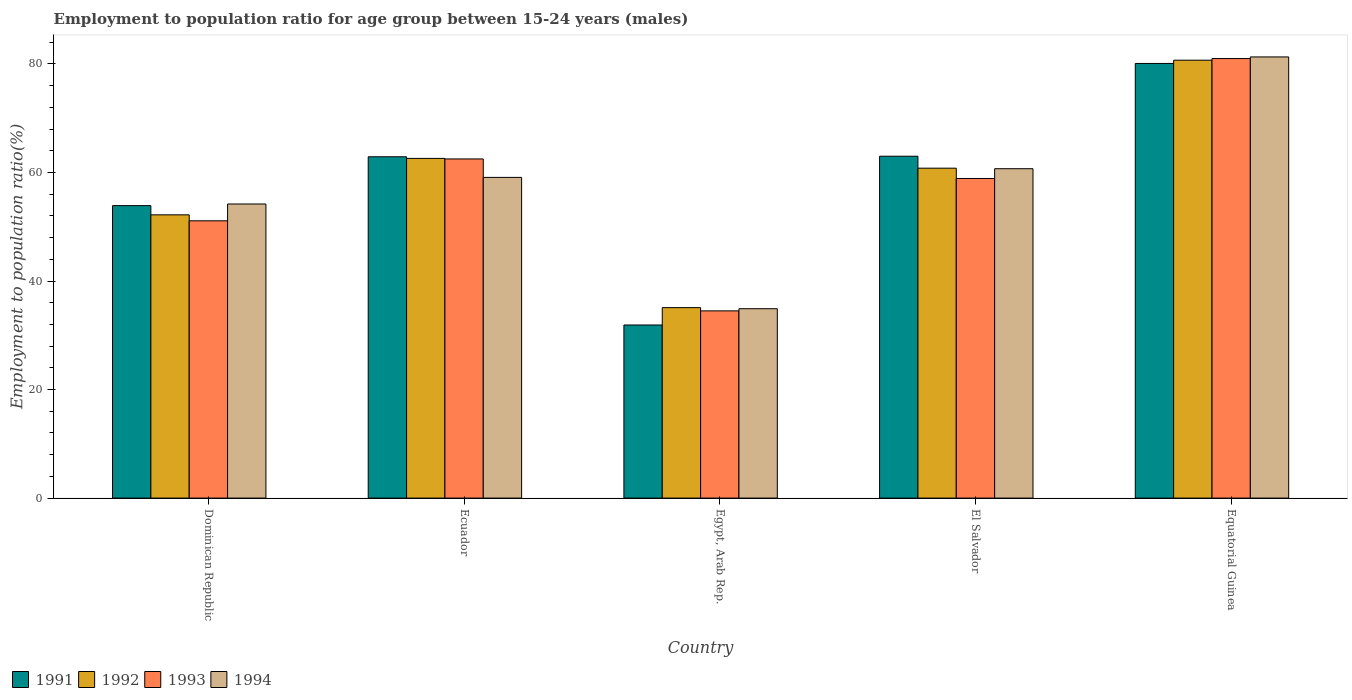How many different coloured bars are there?
Offer a very short reply. 4. How many bars are there on the 3rd tick from the left?
Keep it short and to the point. 4. How many bars are there on the 1st tick from the right?
Make the answer very short. 4. What is the label of the 1st group of bars from the left?
Keep it short and to the point. Dominican Republic. In how many cases, is the number of bars for a given country not equal to the number of legend labels?
Make the answer very short. 0. What is the employment to population ratio in 1994 in Ecuador?
Ensure brevity in your answer.  59.1. Across all countries, what is the maximum employment to population ratio in 1991?
Your answer should be very brief. 80.1. Across all countries, what is the minimum employment to population ratio in 1992?
Your response must be concise. 35.1. In which country was the employment to population ratio in 1991 maximum?
Give a very brief answer. Equatorial Guinea. In which country was the employment to population ratio in 1993 minimum?
Ensure brevity in your answer.  Egypt, Arab Rep. What is the total employment to population ratio in 1991 in the graph?
Offer a very short reply. 291.8. What is the difference between the employment to population ratio in 1994 in Ecuador and that in Egypt, Arab Rep.?
Give a very brief answer. 24.2. What is the difference between the employment to population ratio in 1994 in Equatorial Guinea and the employment to population ratio in 1993 in Ecuador?
Your response must be concise. 18.8. What is the average employment to population ratio in 1992 per country?
Make the answer very short. 58.28. What is the difference between the employment to population ratio of/in 1992 and employment to population ratio of/in 1993 in Egypt, Arab Rep.?
Make the answer very short. 0.6. What is the ratio of the employment to population ratio in 1994 in Ecuador to that in Equatorial Guinea?
Provide a succinct answer. 0.73. Is the difference between the employment to population ratio in 1992 in Dominican Republic and El Salvador greater than the difference between the employment to population ratio in 1993 in Dominican Republic and El Salvador?
Offer a very short reply. No. What is the difference between the highest and the second highest employment to population ratio in 1993?
Offer a terse response. 22.1. What is the difference between the highest and the lowest employment to population ratio in 1993?
Provide a short and direct response. 46.5. Is the sum of the employment to population ratio in 1993 in Dominican Republic and Equatorial Guinea greater than the maximum employment to population ratio in 1994 across all countries?
Your response must be concise. Yes. What does the 2nd bar from the right in Egypt, Arab Rep. represents?
Your answer should be very brief. 1993. Are all the bars in the graph horizontal?
Your answer should be very brief. No. Are the values on the major ticks of Y-axis written in scientific E-notation?
Your answer should be compact. No. How many legend labels are there?
Provide a short and direct response. 4. What is the title of the graph?
Your response must be concise. Employment to population ratio for age group between 15-24 years (males). What is the label or title of the X-axis?
Your answer should be very brief. Country. What is the Employment to population ratio(%) in 1991 in Dominican Republic?
Give a very brief answer. 53.9. What is the Employment to population ratio(%) in 1992 in Dominican Republic?
Provide a succinct answer. 52.2. What is the Employment to population ratio(%) of 1993 in Dominican Republic?
Provide a succinct answer. 51.1. What is the Employment to population ratio(%) in 1994 in Dominican Republic?
Your answer should be compact. 54.2. What is the Employment to population ratio(%) of 1991 in Ecuador?
Provide a succinct answer. 62.9. What is the Employment to population ratio(%) in 1992 in Ecuador?
Give a very brief answer. 62.6. What is the Employment to population ratio(%) in 1993 in Ecuador?
Offer a terse response. 62.5. What is the Employment to population ratio(%) of 1994 in Ecuador?
Your response must be concise. 59.1. What is the Employment to population ratio(%) in 1991 in Egypt, Arab Rep.?
Make the answer very short. 31.9. What is the Employment to population ratio(%) of 1992 in Egypt, Arab Rep.?
Provide a short and direct response. 35.1. What is the Employment to population ratio(%) in 1993 in Egypt, Arab Rep.?
Make the answer very short. 34.5. What is the Employment to population ratio(%) in 1994 in Egypt, Arab Rep.?
Provide a short and direct response. 34.9. What is the Employment to population ratio(%) in 1991 in El Salvador?
Ensure brevity in your answer.  63. What is the Employment to population ratio(%) in 1992 in El Salvador?
Your response must be concise. 60.8. What is the Employment to population ratio(%) in 1993 in El Salvador?
Offer a terse response. 58.9. What is the Employment to population ratio(%) in 1994 in El Salvador?
Your answer should be very brief. 60.7. What is the Employment to population ratio(%) in 1991 in Equatorial Guinea?
Offer a terse response. 80.1. What is the Employment to population ratio(%) in 1992 in Equatorial Guinea?
Offer a terse response. 80.7. What is the Employment to population ratio(%) in 1993 in Equatorial Guinea?
Your response must be concise. 81. What is the Employment to population ratio(%) in 1994 in Equatorial Guinea?
Offer a terse response. 81.3. Across all countries, what is the maximum Employment to population ratio(%) of 1991?
Make the answer very short. 80.1. Across all countries, what is the maximum Employment to population ratio(%) in 1992?
Provide a short and direct response. 80.7. Across all countries, what is the maximum Employment to population ratio(%) in 1994?
Give a very brief answer. 81.3. Across all countries, what is the minimum Employment to population ratio(%) of 1991?
Ensure brevity in your answer.  31.9. Across all countries, what is the minimum Employment to population ratio(%) of 1992?
Keep it short and to the point. 35.1. Across all countries, what is the minimum Employment to population ratio(%) in 1993?
Offer a terse response. 34.5. Across all countries, what is the minimum Employment to population ratio(%) in 1994?
Keep it short and to the point. 34.9. What is the total Employment to population ratio(%) of 1991 in the graph?
Make the answer very short. 291.8. What is the total Employment to population ratio(%) of 1992 in the graph?
Your response must be concise. 291.4. What is the total Employment to population ratio(%) in 1993 in the graph?
Provide a succinct answer. 288. What is the total Employment to population ratio(%) in 1994 in the graph?
Make the answer very short. 290.2. What is the difference between the Employment to population ratio(%) in 1993 in Dominican Republic and that in Ecuador?
Keep it short and to the point. -11.4. What is the difference between the Employment to population ratio(%) of 1994 in Dominican Republic and that in Ecuador?
Your response must be concise. -4.9. What is the difference between the Employment to population ratio(%) of 1991 in Dominican Republic and that in Egypt, Arab Rep.?
Your answer should be compact. 22. What is the difference between the Employment to population ratio(%) in 1992 in Dominican Republic and that in Egypt, Arab Rep.?
Provide a succinct answer. 17.1. What is the difference between the Employment to population ratio(%) in 1993 in Dominican Republic and that in Egypt, Arab Rep.?
Your answer should be compact. 16.6. What is the difference between the Employment to population ratio(%) in 1994 in Dominican Republic and that in Egypt, Arab Rep.?
Make the answer very short. 19.3. What is the difference between the Employment to population ratio(%) in 1992 in Dominican Republic and that in El Salvador?
Offer a very short reply. -8.6. What is the difference between the Employment to population ratio(%) of 1993 in Dominican Republic and that in El Salvador?
Your response must be concise. -7.8. What is the difference between the Employment to population ratio(%) in 1991 in Dominican Republic and that in Equatorial Guinea?
Ensure brevity in your answer.  -26.2. What is the difference between the Employment to population ratio(%) in 1992 in Dominican Republic and that in Equatorial Guinea?
Ensure brevity in your answer.  -28.5. What is the difference between the Employment to population ratio(%) of 1993 in Dominican Republic and that in Equatorial Guinea?
Offer a terse response. -29.9. What is the difference between the Employment to population ratio(%) of 1994 in Dominican Republic and that in Equatorial Guinea?
Your answer should be very brief. -27.1. What is the difference between the Employment to population ratio(%) in 1993 in Ecuador and that in Egypt, Arab Rep.?
Offer a very short reply. 28. What is the difference between the Employment to population ratio(%) of 1994 in Ecuador and that in Egypt, Arab Rep.?
Offer a terse response. 24.2. What is the difference between the Employment to population ratio(%) of 1993 in Ecuador and that in El Salvador?
Offer a very short reply. 3.6. What is the difference between the Employment to population ratio(%) in 1994 in Ecuador and that in El Salvador?
Your answer should be compact. -1.6. What is the difference between the Employment to population ratio(%) of 1991 in Ecuador and that in Equatorial Guinea?
Keep it short and to the point. -17.2. What is the difference between the Employment to population ratio(%) in 1992 in Ecuador and that in Equatorial Guinea?
Ensure brevity in your answer.  -18.1. What is the difference between the Employment to population ratio(%) in 1993 in Ecuador and that in Equatorial Guinea?
Give a very brief answer. -18.5. What is the difference between the Employment to population ratio(%) in 1994 in Ecuador and that in Equatorial Guinea?
Provide a short and direct response. -22.2. What is the difference between the Employment to population ratio(%) in 1991 in Egypt, Arab Rep. and that in El Salvador?
Ensure brevity in your answer.  -31.1. What is the difference between the Employment to population ratio(%) of 1992 in Egypt, Arab Rep. and that in El Salvador?
Your response must be concise. -25.7. What is the difference between the Employment to population ratio(%) of 1993 in Egypt, Arab Rep. and that in El Salvador?
Offer a terse response. -24.4. What is the difference between the Employment to population ratio(%) of 1994 in Egypt, Arab Rep. and that in El Salvador?
Your response must be concise. -25.8. What is the difference between the Employment to population ratio(%) of 1991 in Egypt, Arab Rep. and that in Equatorial Guinea?
Offer a very short reply. -48.2. What is the difference between the Employment to population ratio(%) in 1992 in Egypt, Arab Rep. and that in Equatorial Guinea?
Provide a short and direct response. -45.6. What is the difference between the Employment to population ratio(%) of 1993 in Egypt, Arab Rep. and that in Equatorial Guinea?
Make the answer very short. -46.5. What is the difference between the Employment to population ratio(%) of 1994 in Egypt, Arab Rep. and that in Equatorial Guinea?
Make the answer very short. -46.4. What is the difference between the Employment to population ratio(%) in 1991 in El Salvador and that in Equatorial Guinea?
Your response must be concise. -17.1. What is the difference between the Employment to population ratio(%) in 1992 in El Salvador and that in Equatorial Guinea?
Your answer should be compact. -19.9. What is the difference between the Employment to population ratio(%) of 1993 in El Salvador and that in Equatorial Guinea?
Ensure brevity in your answer.  -22.1. What is the difference between the Employment to population ratio(%) in 1994 in El Salvador and that in Equatorial Guinea?
Provide a short and direct response. -20.6. What is the difference between the Employment to population ratio(%) of 1991 in Dominican Republic and the Employment to population ratio(%) of 1992 in Ecuador?
Offer a very short reply. -8.7. What is the difference between the Employment to population ratio(%) of 1991 in Dominican Republic and the Employment to population ratio(%) of 1994 in Ecuador?
Keep it short and to the point. -5.2. What is the difference between the Employment to population ratio(%) of 1993 in Dominican Republic and the Employment to population ratio(%) of 1994 in Ecuador?
Provide a succinct answer. -8. What is the difference between the Employment to population ratio(%) of 1991 in Dominican Republic and the Employment to population ratio(%) of 1993 in Egypt, Arab Rep.?
Provide a succinct answer. 19.4. What is the difference between the Employment to population ratio(%) in 1991 in Dominican Republic and the Employment to population ratio(%) in 1994 in Egypt, Arab Rep.?
Offer a very short reply. 19. What is the difference between the Employment to population ratio(%) of 1992 in Dominican Republic and the Employment to population ratio(%) of 1993 in Egypt, Arab Rep.?
Your response must be concise. 17.7. What is the difference between the Employment to population ratio(%) of 1992 in Dominican Republic and the Employment to population ratio(%) of 1994 in Egypt, Arab Rep.?
Keep it short and to the point. 17.3. What is the difference between the Employment to population ratio(%) in 1991 in Dominican Republic and the Employment to population ratio(%) in 1992 in El Salvador?
Your answer should be compact. -6.9. What is the difference between the Employment to population ratio(%) in 1992 in Dominican Republic and the Employment to population ratio(%) in 1993 in El Salvador?
Your response must be concise. -6.7. What is the difference between the Employment to population ratio(%) of 1992 in Dominican Republic and the Employment to population ratio(%) of 1994 in El Salvador?
Make the answer very short. -8.5. What is the difference between the Employment to population ratio(%) of 1993 in Dominican Republic and the Employment to population ratio(%) of 1994 in El Salvador?
Make the answer very short. -9.6. What is the difference between the Employment to population ratio(%) in 1991 in Dominican Republic and the Employment to population ratio(%) in 1992 in Equatorial Guinea?
Offer a very short reply. -26.8. What is the difference between the Employment to population ratio(%) of 1991 in Dominican Republic and the Employment to population ratio(%) of 1993 in Equatorial Guinea?
Provide a short and direct response. -27.1. What is the difference between the Employment to population ratio(%) of 1991 in Dominican Republic and the Employment to population ratio(%) of 1994 in Equatorial Guinea?
Make the answer very short. -27.4. What is the difference between the Employment to population ratio(%) in 1992 in Dominican Republic and the Employment to population ratio(%) in 1993 in Equatorial Guinea?
Keep it short and to the point. -28.8. What is the difference between the Employment to population ratio(%) in 1992 in Dominican Republic and the Employment to population ratio(%) in 1994 in Equatorial Guinea?
Provide a succinct answer. -29.1. What is the difference between the Employment to population ratio(%) of 1993 in Dominican Republic and the Employment to population ratio(%) of 1994 in Equatorial Guinea?
Provide a short and direct response. -30.2. What is the difference between the Employment to population ratio(%) of 1991 in Ecuador and the Employment to population ratio(%) of 1992 in Egypt, Arab Rep.?
Offer a terse response. 27.8. What is the difference between the Employment to population ratio(%) in 1991 in Ecuador and the Employment to population ratio(%) in 1993 in Egypt, Arab Rep.?
Your answer should be very brief. 28.4. What is the difference between the Employment to population ratio(%) of 1991 in Ecuador and the Employment to population ratio(%) of 1994 in Egypt, Arab Rep.?
Your answer should be compact. 28. What is the difference between the Employment to population ratio(%) in 1992 in Ecuador and the Employment to population ratio(%) in 1993 in Egypt, Arab Rep.?
Offer a terse response. 28.1. What is the difference between the Employment to population ratio(%) in 1992 in Ecuador and the Employment to population ratio(%) in 1994 in Egypt, Arab Rep.?
Offer a terse response. 27.7. What is the difference between the Employment to population ratio(%) in 1993 in Ecuador and the Employment to population ratio(%) in 1994 in Egypt, Arab Rep.?
Make the answer very short. 27.6. What is the difference between the Employment to population ratio(%) of 1992 in Ecuador and the Employment to population ratio(%) of 1993 in El Salvador?
Keep it short and to the point. 3.7. What is the difference between the Employment to population ratio(%) of 1993 in Ecuador and the Employment to population ratio(%) of 1994 in El Salvador?
Provide a succinct answer. 1.8. What is the difference between the Employment to population ratio(%) of 1991 in Ecuador and the Employment to population ratio(%) of 1992 in Equatorial Guinea?
Provide a short and direct response. -17.8. What is the difference between the Employment to population ratio(%) in 1991 in Ecuador and the Employment to population ratio(%) in 1993 in Equatorial Guinea?
Give a very brief answer. -18.1. What is the difference between the Employment to population ratio(%) of 1991 in Ecuador and the Employment to population ratio(%) of 1994 in Equatorial Guinea?
Provide a short and direct response. -18.4. What is the difference between the Employment to population ratio(%) of 1992 in Ecuador and the Employment to population ratio(%) of 1993 in Equatorial Guinea?
Offer a very short reply. -18.4. What is the difference between the Employment to population ratio(%) of 1992 in Ecuador and the Employment to population ratio(%) of 1994 in Equatorial Guinea?
Provide a succinct answer. -18.7. What is the difference between the Employment to population ratio(%) of 1993 in Ecuador and the Employment to population ratio(%) of 1994 in Equatorial Guinea?
Give a very brief answer. -18.8. What is the difference between the Employment to population ratio(%) in 1991 in Egypt, Arab Rep. and the Employment to population ratio(%) in 1992 in El Salvador?
Your answer should be compact. -28.9. What is the difference between the Employment to population ratio(%) of 1991 in Egypt, Arab Rep. and the Employment to population ratio(%) of 1994 in El Salvador?
Your answer should be compact. -28.8. What is the difference between the Employment to population ratio(%) of 1992 in Egypt, Arab Rep. and the Employment to population ratio(%) of 1993 in El Salvador?
Your response must be concise. -23.8. What is the difference between the Employment to population ratio(%) of 1992 in Egypt, Arab Rep. and the Employment to population ratio(%) of 1994 in El Salvador?
Your answer should be compact. -25.6. What is the difference between the Employment to population ratio(%) in 1993 in Egypt, Arab Rep. and the Employment to population ratio(%) in 1994 in El Salvador?
Your answer should be compact. -26.2. What is the difference between the Employment to population ratio(%) in 1991 in Egypt, Arab Rep. and the Employment to population ratio(%) in 1992 in Equatorial Guinea?
Ensure brevity in your answer.  -48.8. What is the difference between the Employment to population ratio(%) of 1991 in Egypt, Arab Rep. and the Employment to population ratio(%) of 1993 in Equatorial Guinea?
Ensure brevity in your answer.  -49.1. What is the difference between the Employment to population ratio(%) of 1991 in Egypt, Arab Rep. and the Employment to population ratio(%) of 1994 in Equatorial Guinea?
Your response must be concise. -49.4. What is the difference between the Employment to population ratio(%) of 1992 in Egypt, Arab Rep. and the Employment to population ratio(%) of 1993 in Equatorial Guinea?
Give a very brief answer. -45.9. What is the difference between the Employment to population ratio(%) of 1992 in Egypt, Arab Rep. and the Employment to population ratio(%) of 1994 in Equatorial Guinea?
Your response must be concise. -46.2. What is the difference between the Employment to population ratio(%) in 1993 in Egypt, Arab Rep. and the Employment to population ratio(%) in 1994 in Equatorial Guinea?
Provide a succinct answer. -46.8. What is the difference between the Employment to population ratio(%) of 1991 in El Salvador and the Employment to population ratio(%) of 1992 in Equatorial Guinea?
Keep it short and to the point. -17.7. What is the difference between the Employment to population ratio(%) in 1991 in El Salvador and the Employment to population ratio(%) in 1993 in Equatorial Guinea?
Provide a short and direct response. -18. What is the difference between the Employment to population ratio(%) of 1991 in El Salvador and the Employment to population ratio(%) of 1994 in Equatorial Guinea?
Your response must be concise. -18.3. What is the difference between the Employment to population ratio(%) of 1992 in El Salvador and the Employment to population ratio(%) of 1993 in Equatorial Guinea?
Ensure brevity in your answer.  -20.2. What is the difference between the Employment to population ratio(%) of 1992 in El Salvador and the Employment to population ratio(%) of 1994 in Equatorial Guinea?
Give a very brief answer. -20.5. What is the difference between the Employment to population ratio(%) in 1993 in El Salvador and the Employment to population ratio(%) in 1994 in Equatorial Guinea?
Your answer should be very brief. -22.4. What is the average Employment to population ratio(%) in 1991 per country?
Your answer should be very brief. 58.36. What is the average Employment to population ratio(%) in 1992 per country?
Your answer should be compact. 58.28. What is the average Employment to population ratio(%) of 1993 per country?
Provide a succinct answer. 57.6. What is the average Employment to population ratio(%) in 1994 per country?
Make the answer very short. 58.04. What is the difference between the Employment to population ratio(%) of 1991 and Employment to population ratio(%) of 1992 in Dominican Republic?
Ensure brevity in your answer.  1.7. What is the difference between the Employment to population ratio(%) in 1991 and Employment to population ratio(%) in 1994 in Dominican Republic?
Keep it short and to the point. -0.3. What is the difference between the Employment to population ratio(%) of 1992 and Employment to population ratio(%) of 1994 in Dominican Republic?
Your answer should be compact. -2. What is the difference between the Employment to population ratio(%) of 1993 and Employment to population ratio(%) of 1994 in Dominican Republic?
Give a very brief answer. -3.1. What is the difference between the Employment to population ratio(%) of 1991 and Employment to population ratio(%) of 1993 in Ecuador?
Offer a terse response. 0.4. What is the difference between the Employment to population ratio(%) of 1991 and Employment to population ratio(%) of 1992 in Egypt, Arab Rep.?
Keep it short and to the point. -3.2. What is the difference between the Employment to population ratio(%) of 1992 and Employment to population ratio(%) of 1993 in Egypt, Arab Rep.?
Give a very brief answer. 0.6. What is the difference between the Employment to population ratio(%) of 1992 and Employment to population ratio(%) of 1994 in Egypt, Arab Rep.?
Keep it short and to the point. 0.2. What is the difference between the Employment to population ratio(%) in 1993 and Employment to population ratio(%) in 1994 in Egypt, Arab Rep.?
Your answer should be very brief. -0.4. What is the difference between the Employment to population ratio(%) in 1991 and Employment to population ratio(%) in 1992 in El Salvador?
Give a very brief answer. 2.2. What is the difference between the Employment to population ratio(%) of 1991 and Employment to population ratio(%) of 1994 in El Salvador?
Your response must be concise. 2.3. What is the difference between the Employment to population ratio(%) in 1993 and Employment to population ratio(%) in 1994 in El Salvador?
Give a very brief answer. -1.8. What is the difference between the Employment to population ratio(%) in 1991 and Employment to population ratio(%) in 1993 in Equatorial Guinea?
Provide a succinct answer. -0.9. What is the difference between the Employment to population ratio(%) in 1991 and Employment to population ratio(%) in 1994 in Equatorial Guinea?
Ensure brevity in your answer.  -1.2. What is the difference between the Employment to population ratio(%) of 1992 and Employment to population ratio(%) of 1993 in Equatorial Guinea?
Provide a succinct answer. -0.3. What is the difference between the Employment to population ratio(%) in 1993 and Employment to population ratio(%) in 1994 in Equatorial Guinea?
Offer a terse response. -0.3. What is the ratio of the Employment to population ratio(%) of 1991 in Dominican Republic to that in Ecuador?
Give a very brief answer. 0.86. What is the ratio of the Employment to population ratio(%) in 1992 in Dominican Republic to that in Ecuador?
Provide a succinct answer. 0.83. What is the ratio of the Employment to population ratio(%) of 1993 in Dominican Republic to that in Ecuador?
Provide a succinct answer. 0.82. What is the ratio of the Employment to population ratio(%) in 1994 in Dominican Republic to that in Ecuador?
Make the answer very short. 0.92. What is the ratio of the Employment to population ratio(%) in 1991 in Dominican Republic to that in Egypt, Arab Rep.?
Provide a succinct answer. 1.69. What is the ratio of the Employment to population ratio(%) in 1992 in Dominican Republic to that in Egypt, Arab Rep.?
Make the answer very short. 1.49. What is the ratio of the Employment to population ratio(%) in 1993 in Dominican Republic to that in Egypt, Arab Rep.?
Provide a succinct answer. 1.48. What is the ratio of the Employment to population ratio(%) of 1994 in Dominican Republic to that in Egypt, Arab Rep.?
Provide a succinct answer. 1.55. What is the ratio of the Employment to population ratio(%) in 1991 in Dominican Republic to that in El Salvador?
Your answer should be compact. 0.86. What is the ratio of the Employment to population ratio(%) of 1992 in Dominican Republic to that in El Salvador?
Your answer should be very brief. 0.86. What is the ratio of the Employment to population ratio(%) in 1993 in Dominican Republic to that in El Salvador?
Give a very brief answer. 0.87. What is the ratio of the Employment to population ratio(%) of 1994 in Dominican Republic to that in El Salvador?
Keep it short and to the point. 0.89. What is the ratio of the Employment to population ratio(%) in 1991 in Dominican Republic to that in Equatorial Guinea?
Your answer should be very brief. 0.67. What is the ratio of the Employment to population ratio(%) in 1992 in Dominican Republic to that in Equatorial Guinea?
Provide a short and direct response. 0.65. What is the ratio of the Employment to population ratio(%) of 1993 in Dominican Republic to that in Equatorial Guinea?
Provide a succinct answer. 0.63. What is the ratio of the Employment to population ratio(%) of 1991 in Ecuador to that in Egypt, Arab Rep.?
Your response must be concise. 1.97. What is the ratio of the Employment to population ratio(%) of 1992 in Ecuador to that in Egypt, Arab Rep.?
Offer a terse response. 1.78. What is the ratio of the Employment to population ratio(%) of 1993 in Ecuador to that in Egypt, Arab Rep.?
Provide a succinct answer. 1.81. What is the ratio of the Employment to population ratio(%) in 1994 in Ecuador to that in Egypt, Arab Rep.?
Ensure brevity in your answer.  1.69. What is the ratio of the Employment to population ratio(%) of 1992 in Ecuador to that in El Salvador?
Your answer should be very brief. 1.03. What is the ratio of the Employment to population ratio(%) of 1993 in Ecuador to that in El Salvador?
Provide a succinct answer. 1.06. What is the ratio of the Employment to population ratio(%) of 1994 in Ecuador to that in El Salvador?
Your answer should be compact. 0.97. What is the ratio of the Employment to population ratio(%) in 1991 in Ecuador to that in Equatorial Guinea?
Provide a short and direct response. 0.79. What is the ratio of the Employment to population ratio(%) of 1992 in Ecuador to that in Equatorial Guinea?
Keep it short and to the point. 0.78. What is the ratio of the Employment to population ratio(%) of 1993 in Ecuador to that in Equatorial Guinea?
Keep it short and to the point. 0.77. What is the ratio of the Employment to population ratio(%) of 1994 in Ecuador to that in Equatorial Guinea?
Make the answer very short. 0.73. What is the ratio of the Employment to population ratio(%) in 1991 in Egypt, Arab Rep. to that in El Salvador?
Give a very brief answer. 0.51. What is the ratio of the Employment to population ratio(%) in 1992 in Egypt, Arab Rep. to that in El Salvador?
Offer a terse response. 0.58. What is the ratio of the Employment to population ratio(%) in 1993 in Egypt, Arab Rep. to that in El Salvador?
Offer a very short reply. 0.59. What is the ratio of the Employment to population ratio(%) of 1994 in Egypt, Arab Rep. to that in El Salvador?
Offer a very short reply. 0.57. What is the ratio of the Employment to population ratio(%) in 1991 in Egypt, Arab Rep. to that in Equatorial Guinea?
Ensure brevity in your answer.  0.4. What is the ratio of the Employment to population ratio(%) in 1992 in Egypt, Arab Rep. to that in Equatorial Guinea?
Provide a succinct answer. 0.43. What is the ratio of the Employment to population ratio(%) in 1993 in Egypt, Arab Rep. to that in Equatorial Guinea?
Give a very brief answer. 0.43. What is the ratio of the Employment to population ratio(%) in 1994 in Egypt, Arab Rep. to that in Equatorial Guinea?
Offer a very short reply. 0.43. What is the ratio of the Employment to population ratio(%) in 1991 in El Salvador to that in Equatorial Guinea?
Provide a short and direct response. 0.79. What is the ratio of the Employment to population ratio(%) of 1992 in El Salvador to that in Equatorial Guinea?
Give a very brief answer. 0.75. What is the ratio of the Employment to population ratio(%) of 1993 in El Salvador to that in Equatorial Guinea?
Keep it short and to the point. 0.73. What is the ratio of the Employment to population ratio(%) in 1994 in El Salvador to that in Equatorial Guinea?
Keep it short and to the point. 0.75. What is the difference between the highest and the second highest Employment to population ratio(%) of 1994?
Keep it short and to the point. 20.6. What is the difference between the highest and the lowest Employment to population ratio(%) of 1991?
Your answer should be very brief. 48.2. What is the difference between the highest and the lowest Employment to population ratio(%) in 1992?
Provide a short and direct response. 45.6. What is the difference between the highest and the lowest Employment to population ratio(%) of 1993?
Your answer should be compact. 46.5. What is the difference between the highest and the lowest Employment to population ratio(%) of 1994?
Provide a short and direct response. 46.4. 